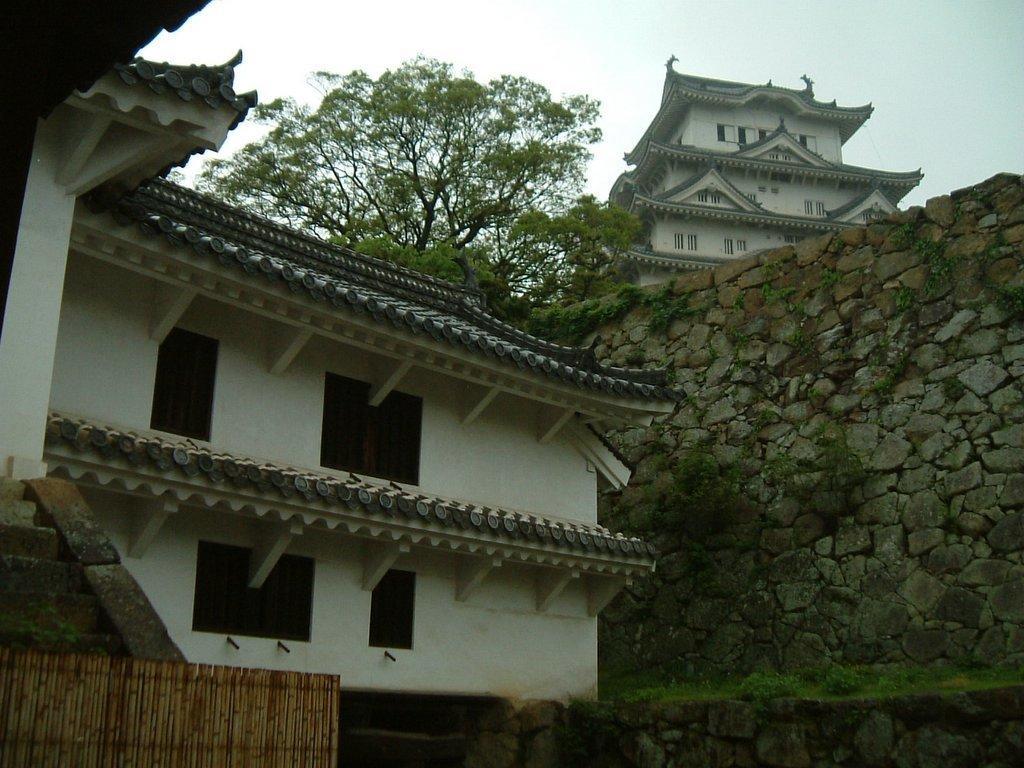Can you describe this image briefly? In the image there is a building on the left side followed by a wall beside it with tree above it and on the right side there is a building on the top and above its sky. 